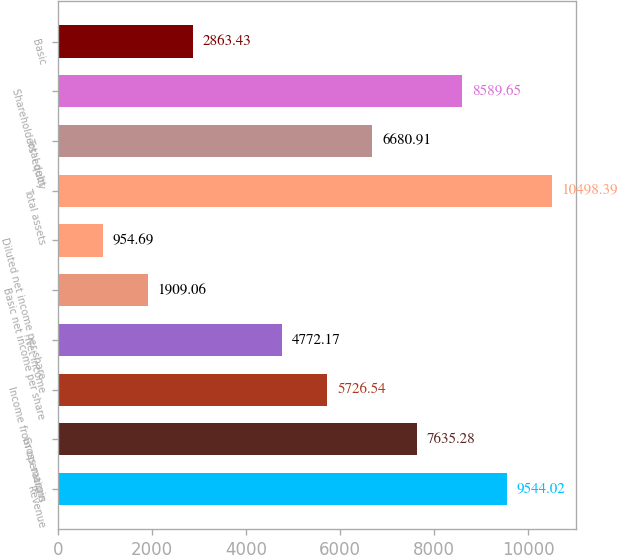<chart> <loc_0><loc_0><loc_500><loc_500><bar_chart><fcel>Revenue<fcel>Gross margin<fcel>Income from operations<fcel>Net income<fcel>Basic net income per share<fcel>Diluted net income per share<fcel>Total assets<fcel>Total debt<fcel>Shareholders' equity<fcel>Basic<nl><fcel>9544.02<fcel>7635.28<fcel>5726.54<fcel>4772.17<fcel>1909.06<fcel>954.69<fcel>10498.4<fcel>6680.91<fcel>8589.65<fcel>2863.43<nl></chart> 